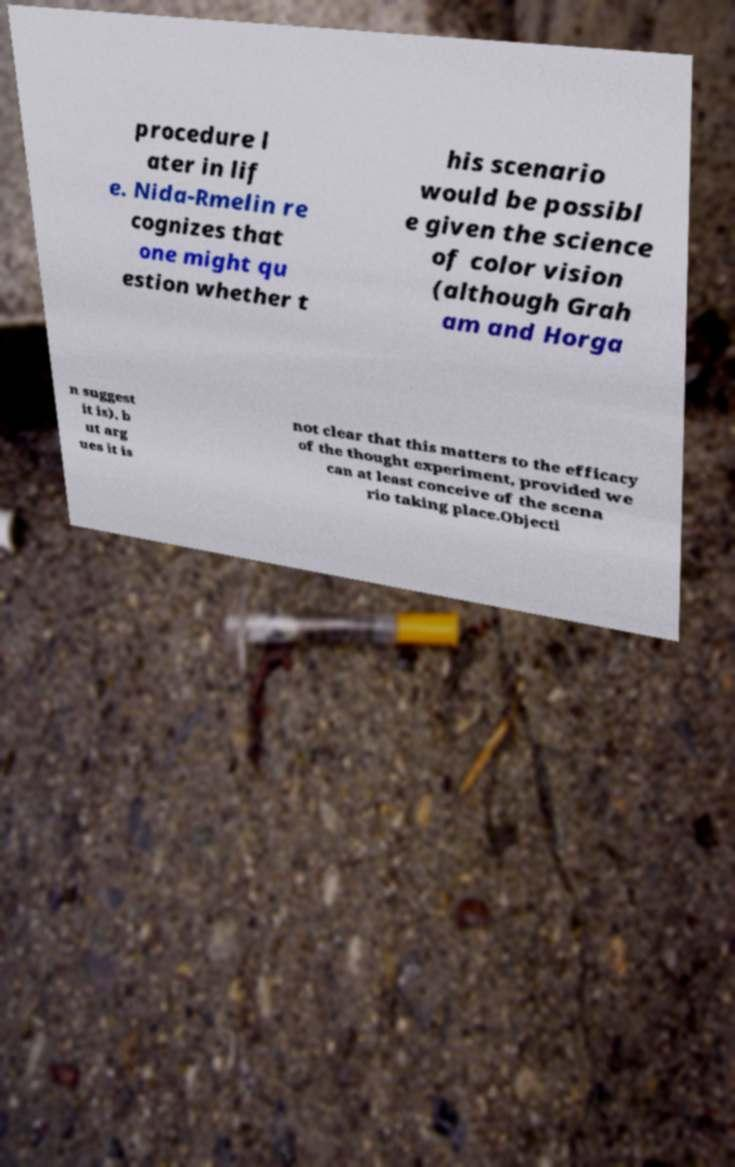For documentation purposes, I need the text within this image transcribed. Could you provide that? procedure l ater in lif e. Nida-Rmelin re cognizes that one might qu estion whether t his scenario would be possibl e given the science of color vision (although Grah am and Horga n suggest it is), b ut arg ues it is not clear that this matters to the efficacy of the thought experiment, provided we can at least conceive of the scena rio taking place.Objecti 